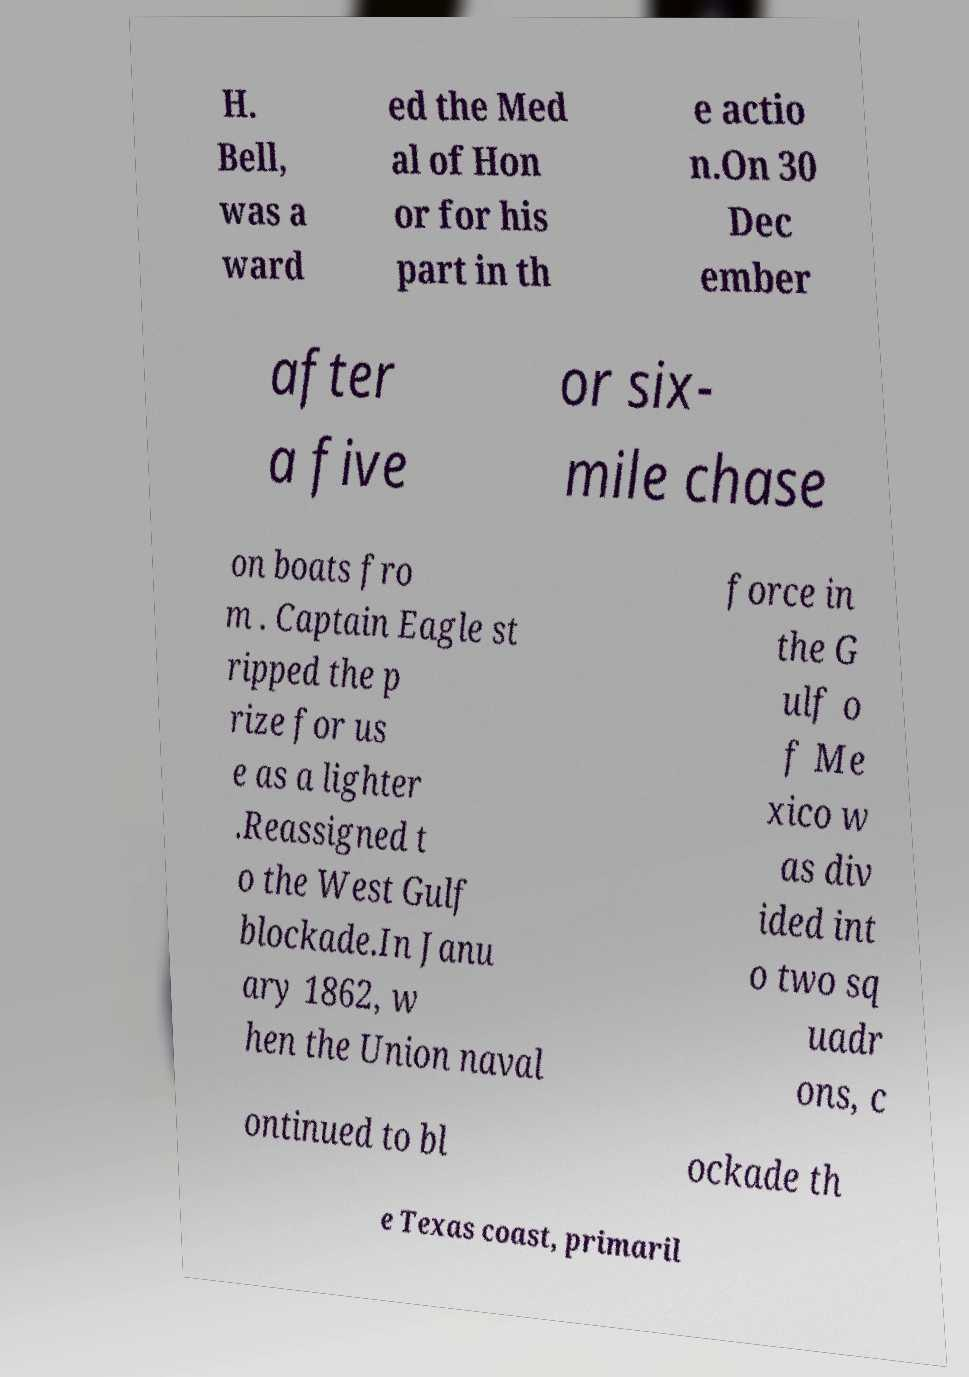What messages or text are displayed in this image? I need them in a readable, typed format. H. Bell, was a ward ed the Med al of Hon or for his part in th e actio n.On 30 Dec ember after a five or six- mile chase on boats fro m . Captain Eagle st ripped the p rize for us e as a lighter .Reassigned t o the West Gulf blockade.In Janu ary 1862, w hen the Union naval force in the G ulf o f Me xico w as div ided int o two sq uadr ons, c ontinued to bl ockade th e Texas coast, primaril 